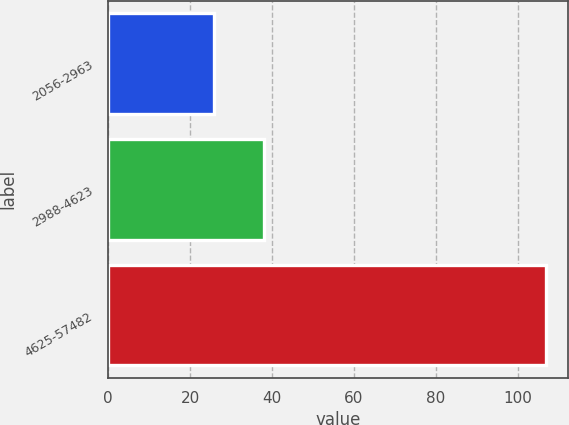Convert chart. <chart><loc_0><loc_0><loc_500><loc_500><bar_chart><fcel>2056-2963<fcel>2988-4623<fcel>4625-57482<nl><fcel>25.9<fcel>38.05<fcel>106.95<nl></chart> 